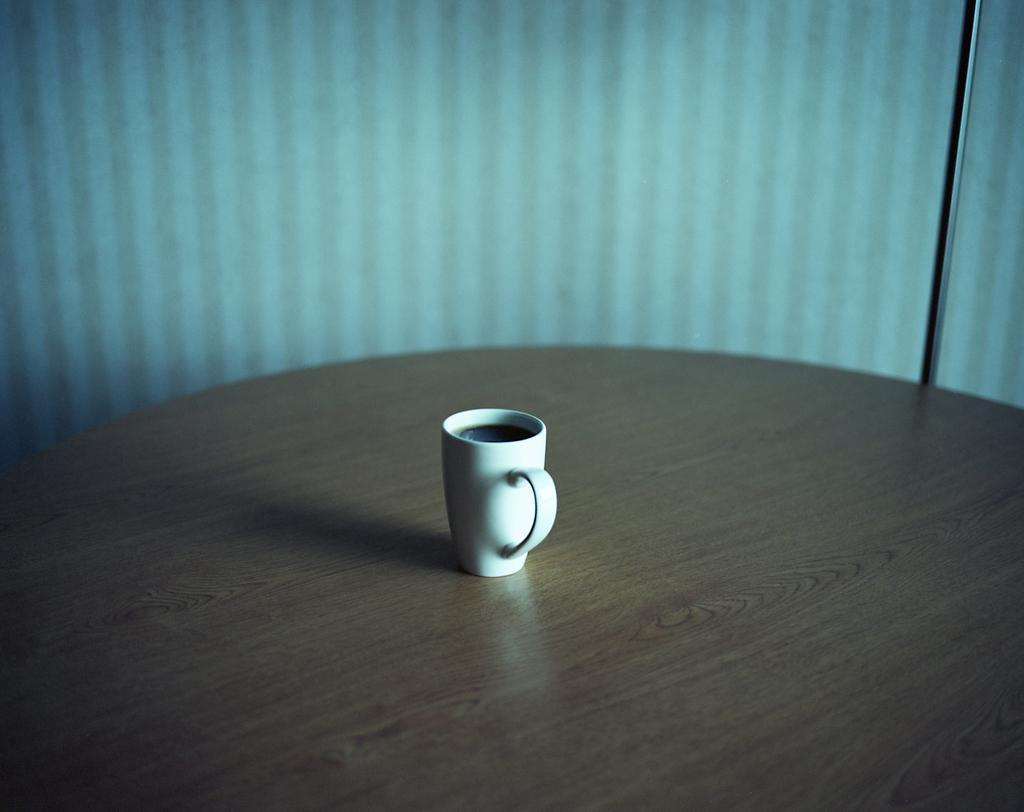Please provide a concise description of this image. In this picture we can see a white colour cup on the table. 